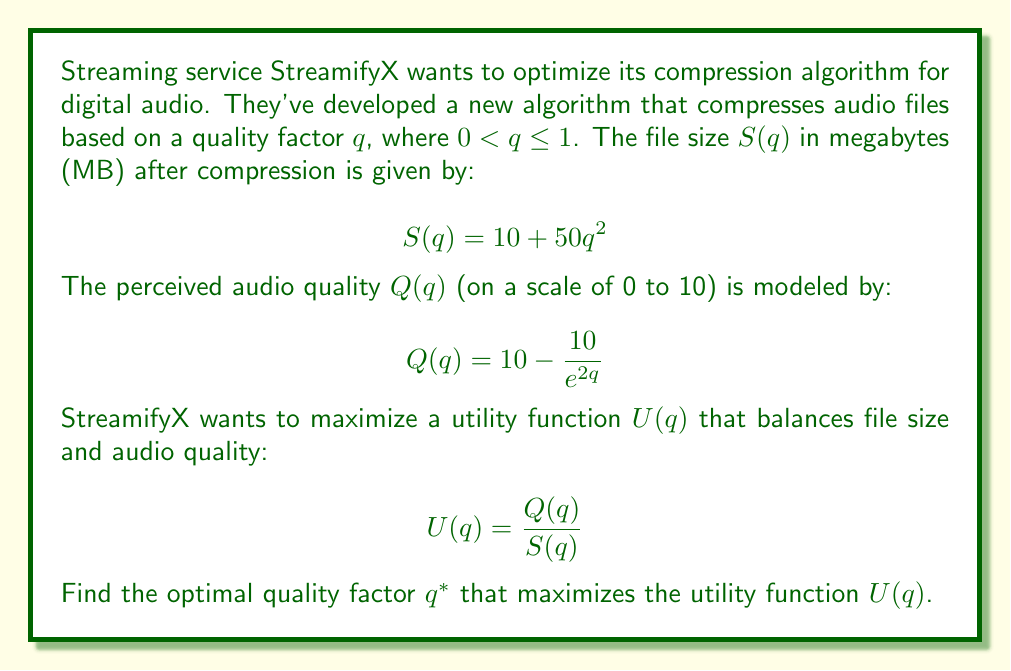Solve this math problem. To find the optimal quality factor $q^*$, we need to maximize the utility function $U(q)$. This can be done by finding the value of $q$ where the derivative of $U(q)$ equals zero.

1. First, let's write out the full utility function:

   $$U(q) = \frac{Q(q)}{S(q)} = \frac{10 - \frac{10}{e^{2q}}}{10 + 50q^2}$$

2. Now, we need to find $\frac{dU}{dq}$ and set it equal to zero:

   $$\frac{dU}{dq} = \frac{(10 + 50q^2) \cdot \frac{d}{dq}(10 - \frac{10}{e^{2q}}) - (10 - \frac{10}{e^{2q}}) \cdot \frac{d}{dq}(10 + 50q^2)}{(10 + 50q^2)^2} = 0$$

3. Simplifying the derivatives:

   $$\frac{(10 + 50q^2) \cdot (\frac{20}{e^{2q}}) - (10 - \frac{10}{e^{2q}}) \cdot (100q)}{(10 + 50q^2)^2} = 0$$

4. Multiplying both sides by $(10 + 50q^2)^2$ (since it's always positive):

   $$(10 + 50q^2) \cdot (\frac{20}{e^{2q}}) - (10 - \frac{10}{e^{2q}}) \cdot (100q) = 0$$

5. Expanding:

   $$\frac{200 + 1000q^2}{e^{2q}} - 1000q + \frac{1000q}{e^{2q}} = 0$$

6. Multiplying all terms by $e^{2q}$:

   $$200 + 1000q^2 - 1000qe^{2q} + 1000q = 0$$

7. Rearranging:

   $$1000q^2 - 1000q(e^{2q} - 1) + 200 = 0$$

This equation cannot be solved analytically. We need to use numerical methods to find the solution. Using a computer algebra system or numerical solver, we can find that the equation is satisfied when $q \approx 0.2843$.

To verify that this is indeed a maximum, we can check the second derivative at this point or plot the function to confirm it's a global maximum in the interval $(0, 1]$.
Answer: The optimal quality factor $q^*$ that maximizes the utility function $U(q)$ is approximately 0.2843. 